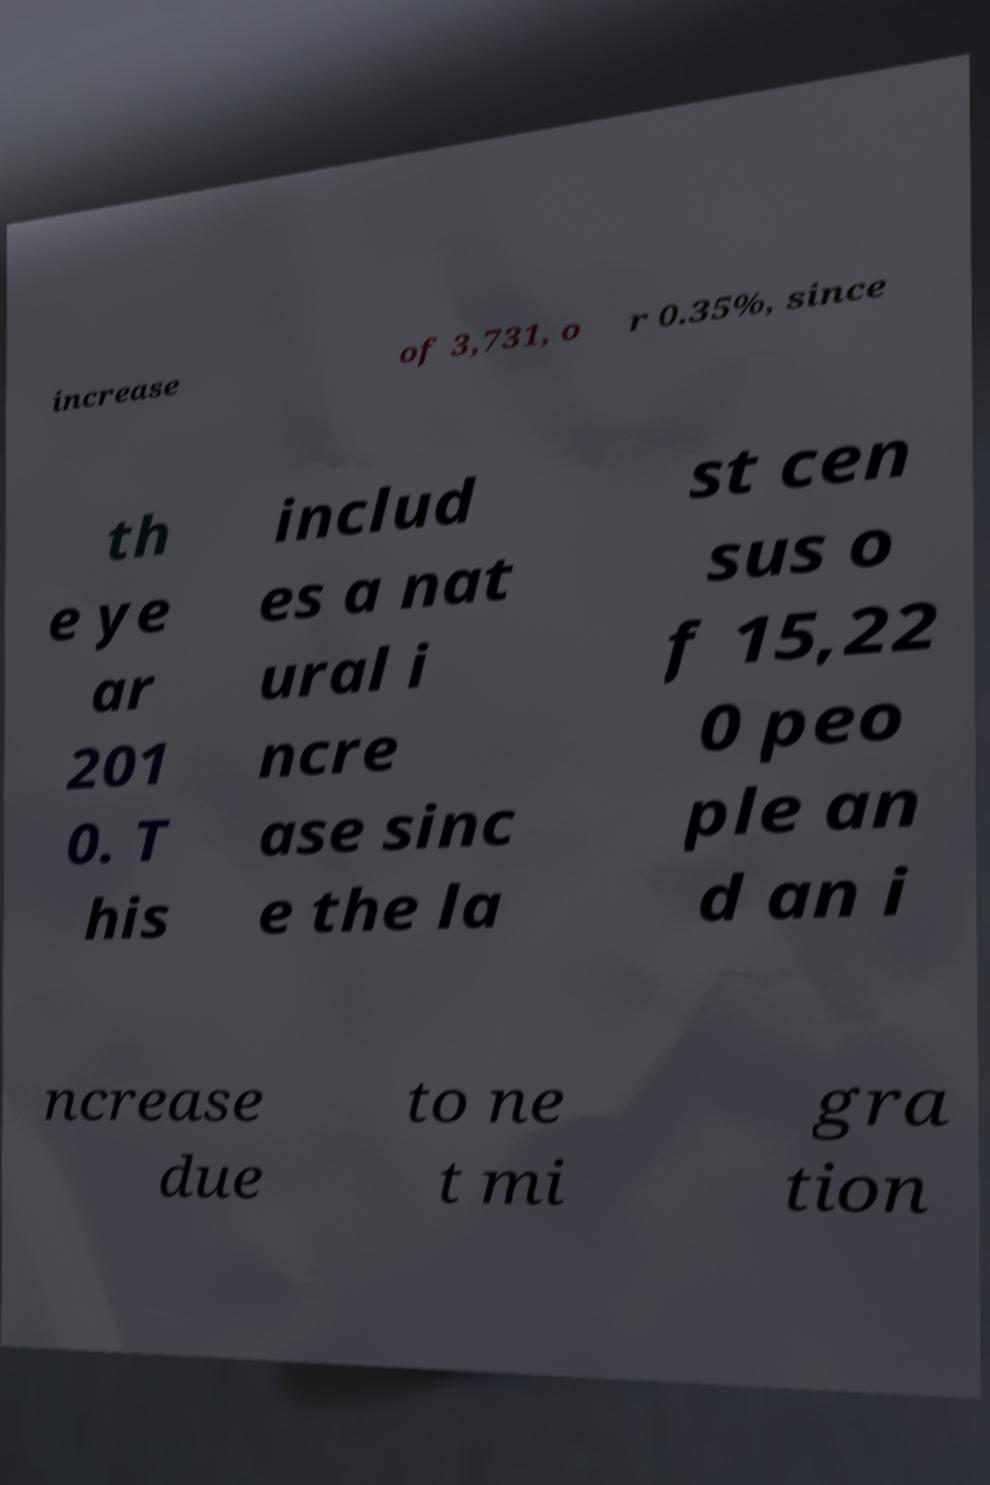Could you assist in decoding the text presented in this image and type it out clearly? increase of 3,731, o r 0.35%, since th e ye ar 201 0. T his includ es a nat ural i ncre ase sinc e the la st cen sus o f 15,22 0 peo ple an d an i ncrease due to ne t mi gra tion 